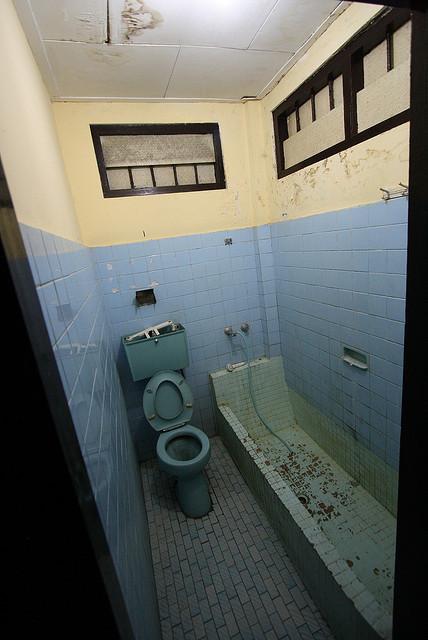How many toilets are seen?
Keep it brief. 1. Is this a bathroom you would use?
Be succinct. No. Are the walls one color?
Be succinct. No. Is this clean?
Give a very brief answer. No. What room is this?
Concise answer only. Bathroom. Is the toilet lid closed?
Answer briefly. No. Is there toilet paper on the holder?
Concise answer only. No. 